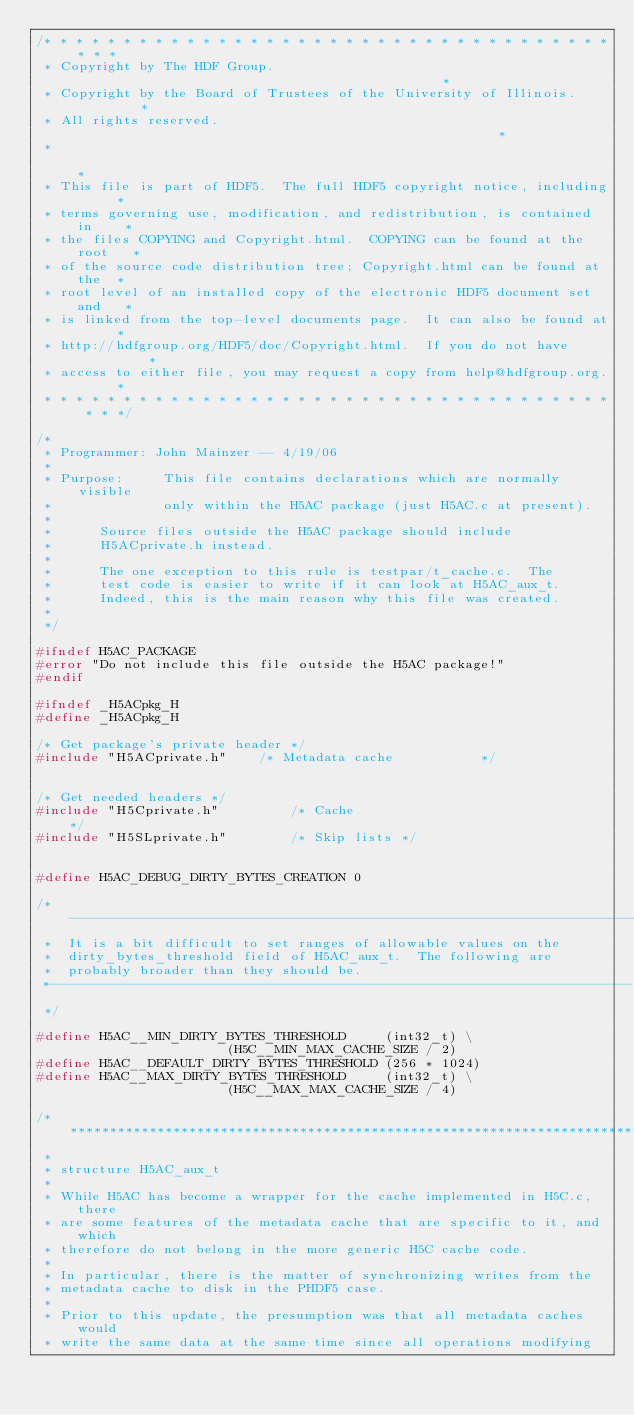<code> <loc_0><loc_0><loc_500><loc_500><_C_>/* * * * * * * * * * * * * * * * * * * * * * * * * * * * * * * * * * * * * * *
 * Copyright by The HDF Group.                                               *
 * Copyright by the Board of Trustees of the University of Illinois.         *
 * All rights reserved.                                                      *
 *                                                                           *
 * This file is part of HDF5.  The full HDF5 copyright notice, including     *
 * terms governing use, modification, and redistribution, is contained in    *
 * the files COPYING and Copyright.html.  COPYING can be found at the root   *
 * of the source code distribution tree; Copyright.html can be found at the  *
 * root level of an installed copy of the electronic HDF5 document set and   *
 * is linked from the top-level documents page.  It can also be found at     *
 * http://hdfgroup.org/HDF5/doc/Copyright.html.  If you do not have          *
 * access to either file, you may request a copy from help@hdfgroup.org.     *
 * * * * * * * * * * * * * * * * * * * * * * * * * * * * * * * * * * * * * * */

/*
 * Programmer: John Mainzer -- 4/19/06
 *
 * Purpose:     This file contains declarations which are normally visible
 *              only within the H5AC package (just H5AC.c at present).
 *
 *		Source files outside the H5AC package should include
 *		H5ACprivate.h instead.
 *
 *		The one exception to this rule is testpar/t_cache.c.  The
 *		test code is easier to write if it can look at H5AC_aux_t.
 *		Indeed, this is the main reason why this file was created.
 *
 */

#ifndef H5AC_PACKAGE
#error "Do not include this file outside the H5AC package!"
#endif

#ifndef _H5ACpkg_H
#define _H5ACpkg_H

/* Get package's private header */
#include "H5ACprivate.h"	/* Metadata cache			*/


/* Get needed headers */
#include "H5Cprivate.h"         /* Cache                                */
#include "H5SLprivate.h"        /* Skip lists */


#define H5AC_DEBUG_DIRTY_BYTES_CREATION	0

/*-------------------------------------------------------------------------
 *  It is a bit difficult to set ranges of allowable values on the
 *  dirty_bytes_threshold field of H5AC_aux_t.  The following are
 *  probably broader than they should be.
 *-------------------------------------------------------------------------
 */

#define H5AC__MIN_DIRTY_BYTES_THRESHOLD		(int32_t) \
						(H5C__MIN_MAX_CACHE_SIZE / 2)
#define H5AC__DEFAULT_DIRTY_BYTES_THRESHOLD	(256 * 1024)
#define H5AC__MAX_DIRTY_BYTES_THRESHOLD   	(int32_t) \
						(H5C__MAX_MAX_CACHE_SIZE / 4)

/****************************************************************************
 *
 * structure H5AC_aux_t
 *
 * While H5AC has become a wrapper for the cache implemented in H5C.c, there
 * are some features of the metadata cache that are specific to it, and which
 * therefore do not belong in the more generic H5C cache code.
 *
 * In particular, there is the matter of synchronizing writes from the
 * metadata cache to disk in the PHDF5 case.
 *
 * Prior to this update, the presumption was that all metadata caches would
 * write the same data at the same time since all operations modifying</code> 